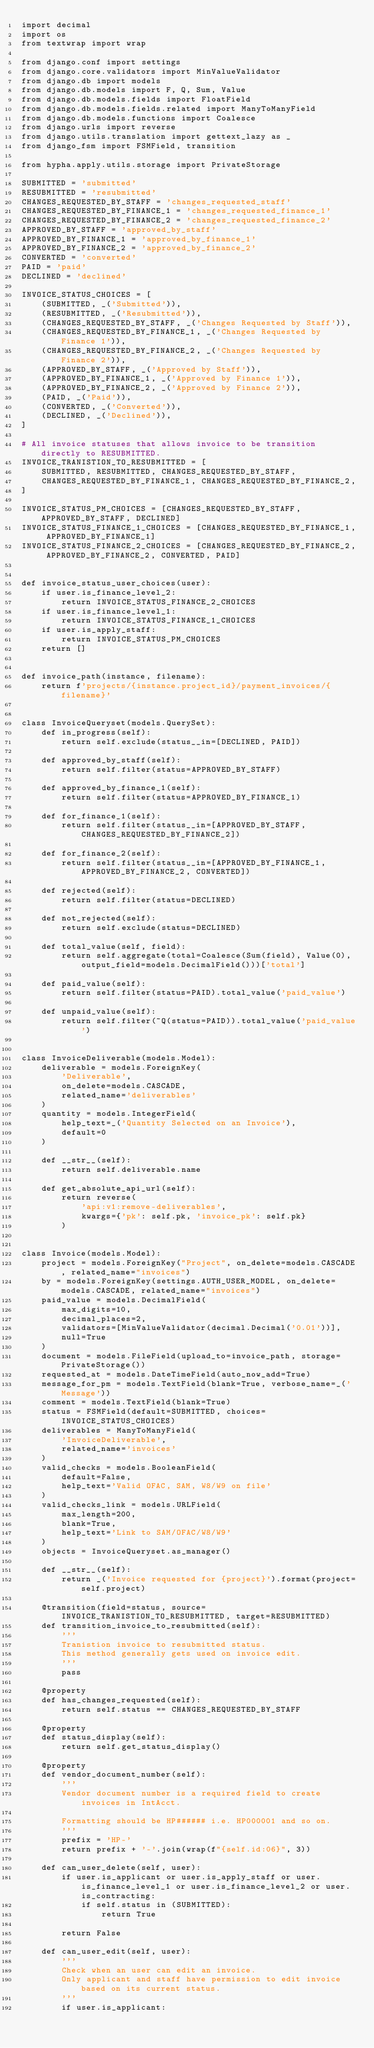Convert code to text. <code><loc_0><loc_0><loc_500><loc_500><_Python_>import decimal
import os
from textwrap import wrap

from django.conf import settings
from django.core.validators import MinValueValidator
from django.db import models
from django.db.models import F, Q, Sum, Value
from django.db.models.fields import FloatField
from django.db.models.fields.related import ManyToManyField
from django.db.models.functions import Coalesce
from django.urls import reverse
from django.utils.translation import gettext_lazy as _
from django_fsm import FSMField, transition

from hypha.apply.utils.storage import PrivateStorage

SUBMITTED = 'submitted'
RESUBMITTED = 'resubmitted'
CHANGES_REQUESTED_BY_STAFF = 'changes_requested_staff'
CHANGES_REQUESTED_BY_FINANCE_1 = 'changes_requested_finance_1'
CHANGES_REQUESTED_BY_FINANCE_2 = 'changes_requested_finance_2'
APPROVED_BY_STAFF = 'approved_by_staff'
APPROVED_BY_FINANCE_1 = 'approved_by_finance_1'
APPROVED_BY_FINANCE_2 = 'approved_by_finance_2'
CONVERTED = 'converted'
PAID = 'paid'
DECLINED = 'declined'

INVOICE_STATUS_CHOICES = [
    (SUBMITTED, _('Submitted')),
    (RESUBMITTED, _('Resubmitted')),
    (CHANGES_REQUESTED_BY_STAFF, _('Changes Requested by Staff')),
    (CHANGES_REQUESTED_BY_FINANCE_1, _('Changes Requested by Finance 1')),
    (CHANGES_REQUESTED_BY_FINANCE_2, _('Changes Requested by Finance 2')),
    (APPROVED_BY_STAFF, _('Approved by Staff')),
    (APPROVED_BY_FINANCE_1, _('Approved by Finance 1')),
    (APPROVED_BY_FINANCE_2, _('Approved by Finance 2')),
    (PAID, _('Paid')),
    (CONVERTED, _('Converted')),
    (DECLINED, _('Declined')),
]

# All invoice statuses that allows invoice to be transition directly to RESUBMITTED.
INVOICE_TRANISTION_TO_RESUBMITTED = [
    SUBMITTED, RESUBMITTED, CHANGES_REQUESTED_BY_STAFF,
    CHANGES_REQUESTED_BY_FINANCE_1, CHANGES_REQUESTED_BY_FINANCE_2,
]

INVOICE_STATUS_PM_CHOICES = [CHANGES_REQUESTED_BY_STAFF, APPROVED_BY_STAFF, DECLINED]
INVOICE_STATUS_FINANCE_1_CHOICES = [CHANGES_REQUESTED_BY_FINANCE_1, APPROVED_BY_FINANCE_1]
INVOICE_STATUS_FINANCE_2_CHOICES = [CHANGES_REQUESTED_BY_FINANCE_2, APPROVED_BY_FINANCE_2, CONVERTED, PAID]


def invoice_status_user_choices(user):
    if user.is_finance_level_2:
        return INVOICE_STATUS_FINANCE_2_CHOICES
    if user.is_finance_level_1:
        return INVOICE_STATUS_FINANCE_1_CHOICES
    if user.is_apply_staff:
        return INVOICE_STATUS_PM_CHOICES
    return []


def invoice_path(instance, filename):
    return f'projects/{instance.project_id}/payment_invoices/{filename}'


class InvoiceQueryset(models.QuerySet):
    def in_progress(self):
        return self.exclude(status__in=[DECLINED, PAID])

    def approved_by_staff(self):
        return self.filter(status=APPROVED_BY_STAFF)

    def approved_by_finance_1(self):
        return self.filter(status=APPROVED_BY_FINANCE_1)

    def for_finance_1(self):
        return self.filter(status__in=[APPROVED_BY_STAFF, CHANGES_REQUESTED_BY_FINANCE_2])

    def for_finance_2(self):
        return self.filter(status__in=[APPROVED_BY_FINANCE_1, APPROVED_BY_FINANCE_2, CONVERTED])

    def rejected(self):
        return self.filter(status=DECLINED)

    def not_rejected(self):
        return self.exclude(status=DECLINED)

    def total_value(self, field):
        return self.aggregate(total=Coalesce(Sum(field), Value(0), output_field=models.DecimalField()))['total']

    def paid_value(self):
        return self.filter(status=PAID).total_value('paid_value')

    def unpaid_value(self):
        return self.filter(~Q(status=PAID)).total_value('paid_value')


class InvoiceDeliverable(models.Model):
    deliverable = models.ForeignKey(
        'Deliverable',
        on_delete=models.CASCADE,
        related_name='deliverables'
    )
    quantity = models.IntegerField(
        help_text=_('Quantity Selected on an Invoice'),
        default=0
    )

    def __str__(self):
        return self.deliverable.name

    def get_absolute_api_url(self):
        return reverse(
            'api:v1:remove-deliverables',
            kwargs={'pk': self.pk, 'invoice_pk': self.pk}
        )


class Invoice(models.Model):
    project = models.ForeignKey("Project", on_delete=models.CASCADE, related_name="invoices")
    by = models.ForeignKey(settings.AUTH_USER_MODEL, on_delete=models.CASCADE, related_name="invoices")
    paid_value = models.DecimalField(
        max_digits=10,
        decimal_places=2,
        validators=[MinValueValidator(decimal.Decimal('0.01'))],
        null=True
    )
    document = models.FileField(upload_to=invoice_path, storage=PrivateStorage())
    requested_at = models.DateTimeField(auto_now_add=True)
    message_for_pm = models.TextField(blank=True, verbose_name=_('Message'))
    comment = models.TextField(blank=True)
    status = FSMField(default=SUBMITTED, choices=INVOICE_STATUS_CHOICES)
    deliverables = ManyToManyField(
        'InvoiceDeliverable',
        related_name='invoices'
    )
    valid_checks = models.BooleanField(
        default=False,
        help_text='Valid OFAC, SAM, W8/W9 on file'
    )
    valid_checks_link = models.URLField(
        max_length=200,
        blank=True,
        help_text='Link to SAM/OFAC/W8/W9'
    )
    objects = InvoiceQueryset.as_manager()

    def __str__(self):
        return _('Invoice requested for {project}').format(project=self.project)

    @transition(field=status, source=INVOICE_TRANISTION_TO_RESUBMITTED, target=RESUBMITTED)
    def transition_invoice_to_resubmitted(self):
        '''
        Tranistion invoice to resubmitted status.
        This method generally gets used on invoice edit.
        '''
        pass

    @property
    def has_changes_requested(self):
        return self.status == CHANGES_REQUESTED_BY_STAFF

    @property
    def status_display(self):
        return self.get_status_display()

    @property
    def vendor_document_number(self):
        '''
        Vendor document number is a required field to create invoices in IntAcct.

        Formatting should be HP###### i.e. HP000001 and so on.
        '''
        prefix = 'HP-'
        return prefix + '-'.join(wrap(f"{self.id:06}", 3))

    def can_user_delete(self, user):
        if user.is_applicant or user.is_apply_staff or user.is_finance_level_1 or user.is_finance_level_2 or user.is_contracting:
            if self.status in (SUBMITTED):
                return True

        return False

    def can_user_edit(self, user):
        '''
        Check when an user can edit an invoice.
        Only applicant and staff have permission to edit invoice based on its current status.
        '''
        if user.is_applicant:</code> 